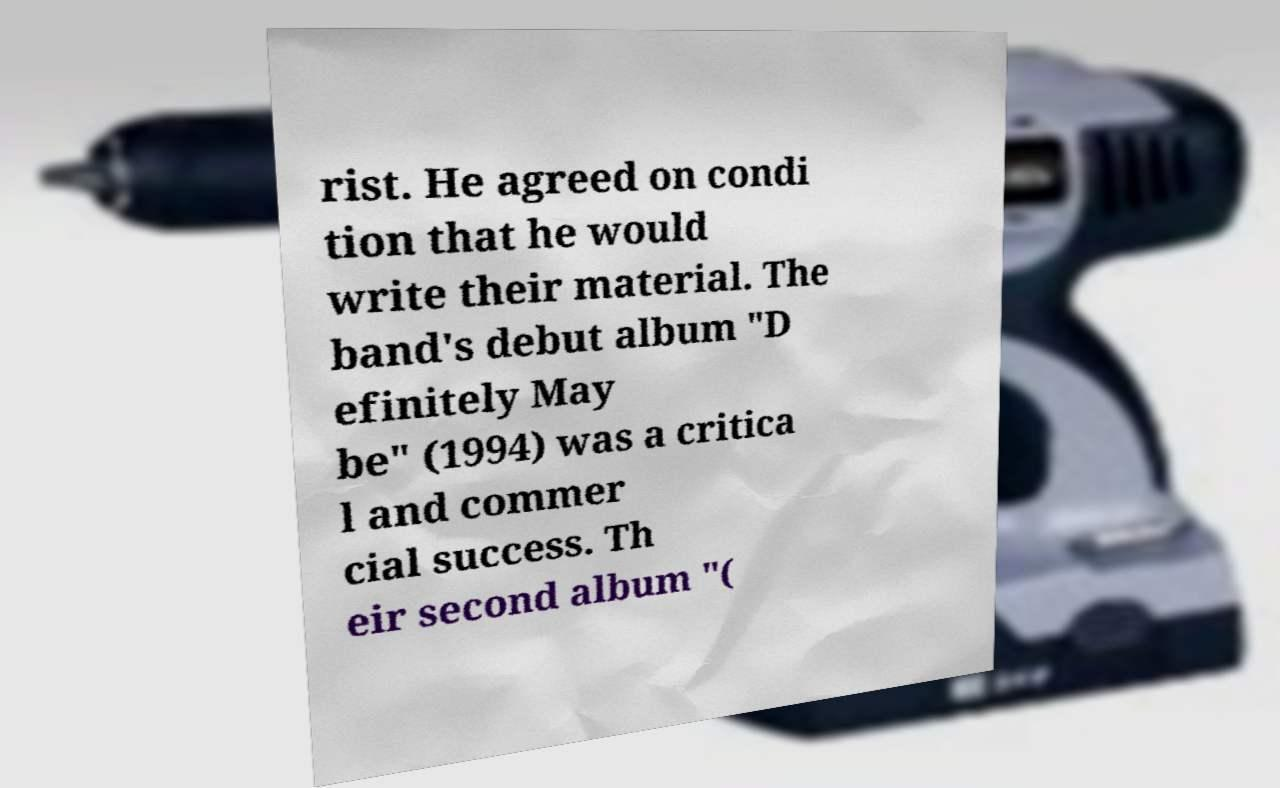Could you assist in decoding the text presented in this image and type it out clearly? rist. He agreed on condi tion that he would write their material. The band's debut album "D efinitely May be" (1994) was a critica l and commer cial success. Th eir second album "( 